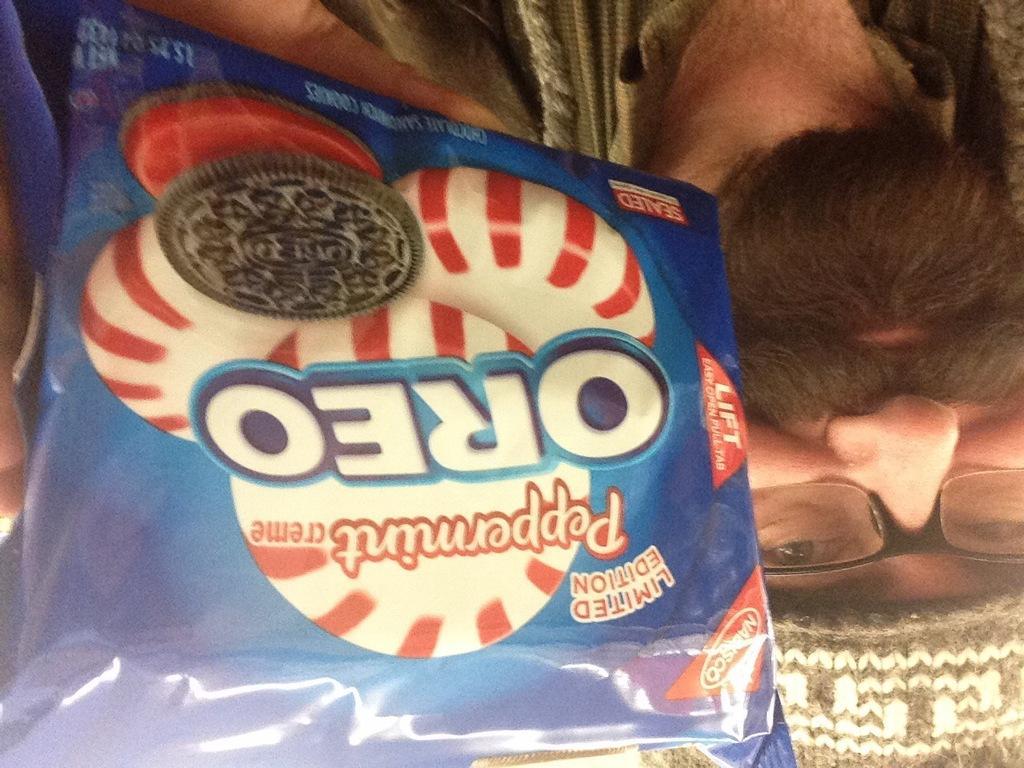Please provide a concise description of this image. In the picture we can see a biscuit packet hold by the person and mentioned in it as an OREO and a biscuit symbol on it and the man is with the beard. 